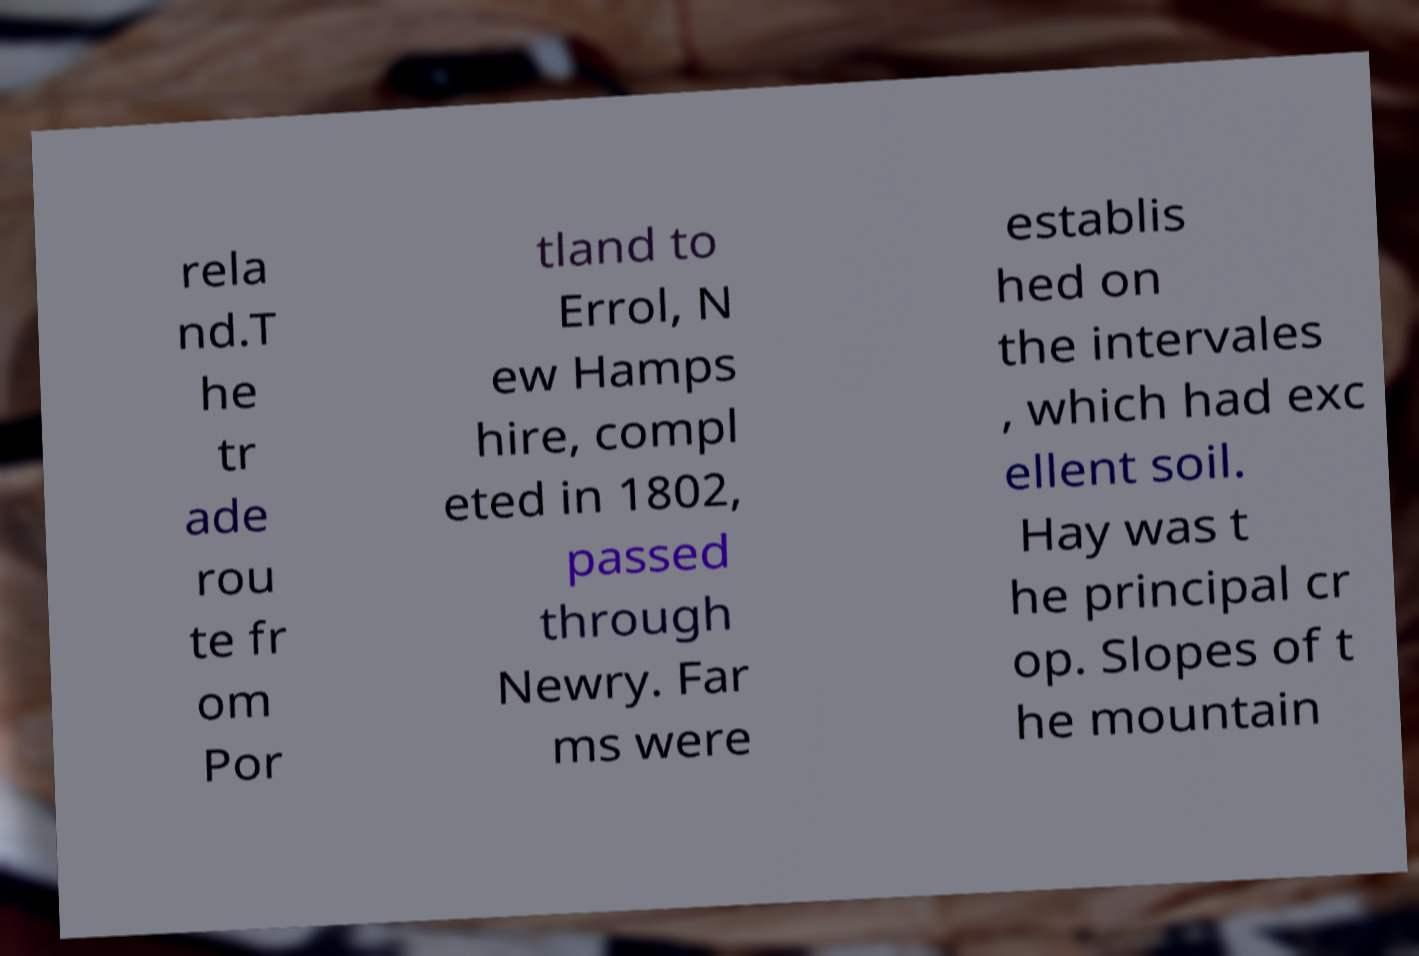There's text embedded in this image that I need extracted. Can you transcribe it verbatim? rela nd.T he tr ade rou te fr om Por tland to Errol, N ew Hamps hire, compl eted in 1802, passed through Newry. Far ms were establis hed on the intervales , which had exc ellent soil. Hay was t he principal cr op. Slopes of t he mountain 